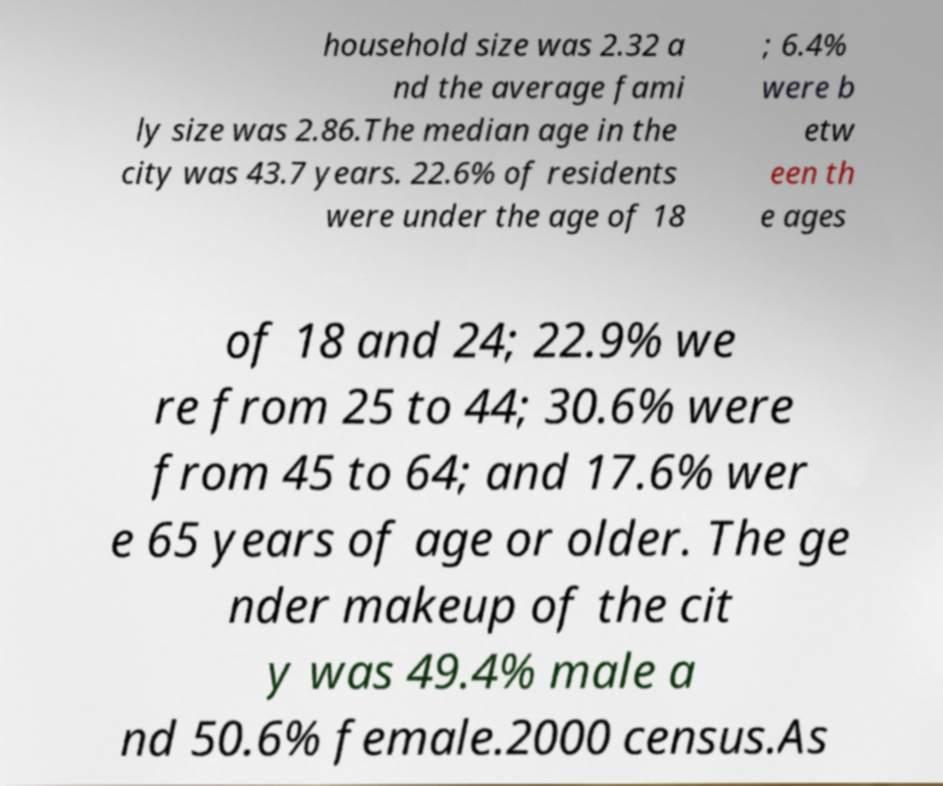There's text embedded in this image that I need extracted. Can you transcribe it verbatim? household size was 2.32 a nd the average fami ly size was 2.86.The median age in the city was 43.7 years. 22.6% of residents were under the age of 18 ; 6.4% were b etw een th e ages of 18 and 24; 22.9% we re from 25 to 44; 30.6% were from 45 to 64; and 17.6% wer e 65 years of age or older. The ge nder makeup of the cit y was 49.4% male a nd 50.6% female.2000 census.As 